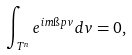Convert formula to latex. <formula><loc_0><loc_0><loc_500><loc_500>\int _ { T ^ { n } } e ^ { i m \i p v } d v = 0 ,</formula> 